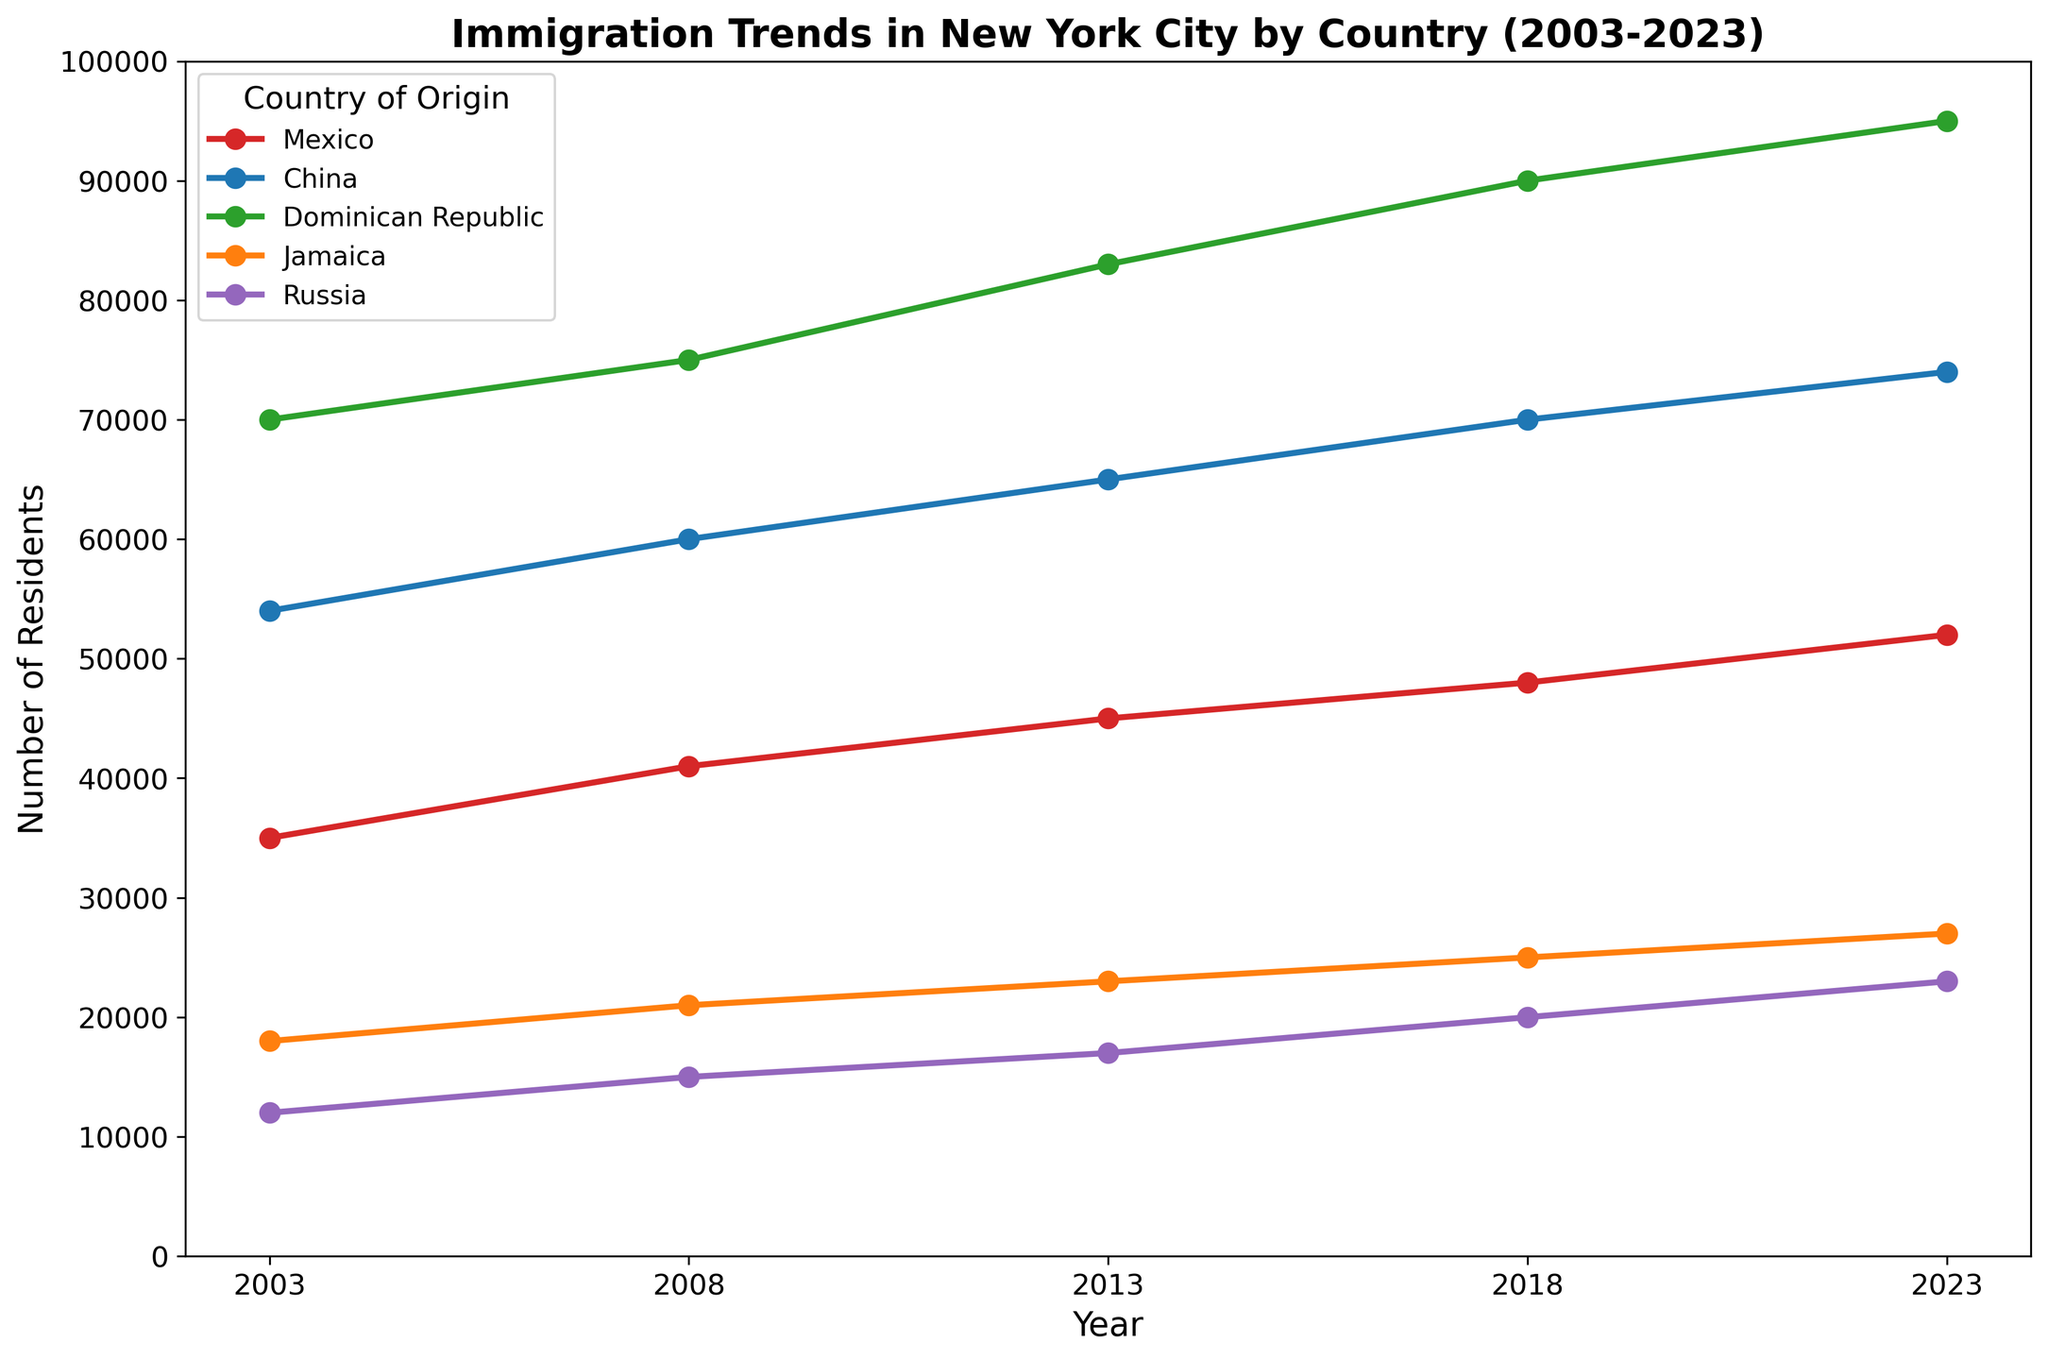What is the trend in the number of residents from the Dominican Republic between 2003 and 2023? Observing the plot, we can see that the line for the Dominican Republic (green line) consistently increases from 70,000 residents in 2003 to 95,000 residents in 2023. This demonstrates a steady upward trend.
Answer: Increasing trend Which country had the highest number of residents in New York City in 2023? In 2023, the line at the top of the plot corresponds to the Dominican Republic, which has approximately 95,000 residents.
Answer: Dominican Republic How many more residents from Jamaica were there in 2023 compared to 2003? In the plot, Jamaica (orange line) shows an increase from 18,000 residents in 2003 to 27,000 residents in 2023. The difference is 27,000 - 18,000 = 9,000.
Answer: 9,000 Which country showed the greatest increase in the number of residents between 2003 and 2023? By observing the differences in the plot lines, the Dominican Republic (green line) has increased from 70,000 in 2003 to 95,000 in 2023, an increase of 25,000, which is the greatest among the countries listed.
Answer: Dominican Republic Did the number of Chinese residents ever decrease over the years shown in the figure? By examining the line for China (blue line), we can see a consistent upward trend from 54,000 in 2003 to 74,000 in 2023 without any decreases.
Answer: No What was the average number of residents from Mexico across the data points provided? The number of residents from Mexico in the years available are 35,000, 41,000, 45,000, 48,000, and 52,000. The average is (35,000 + 41,000 + 45,000 + 48,000 + 52,000) / 5 = 44,200.
Answer: 44,200 Which country had the smallest number of residents in New York City in 2003 and 2023? In 2003, Russia (purple line) had the smallest number of residents at 12,000. In 2023, Russia continues to have the smallest number of residents at 23,000.
Answer: Russia By how much did the number of residents from China increase from 2003 to 2018? The Chinese population increased from 54,000 in 2003 to 70,000 in 2018. The increase is 70,000 - 54,000 = 16,000.
Answer: 16,000 